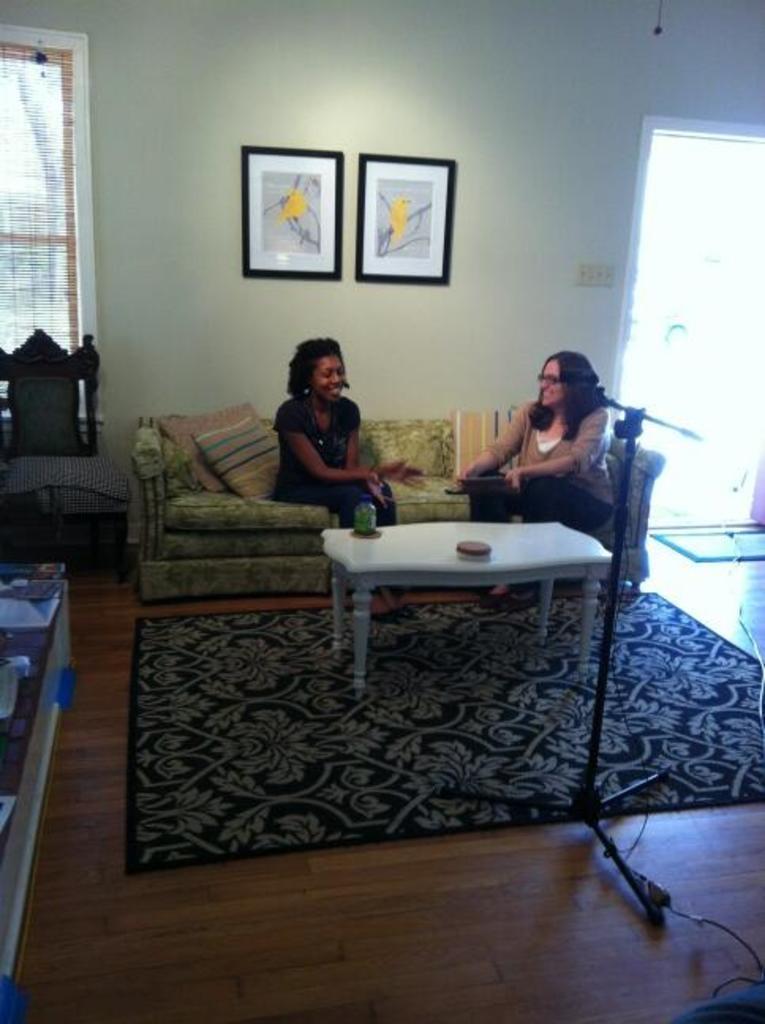In one or two sentences, can you explain what this image depicts? There are two persons sitting on a sofa and there is a table and a black stand in front of them and there are two paintings on the wall and there is a door opened in the background. 